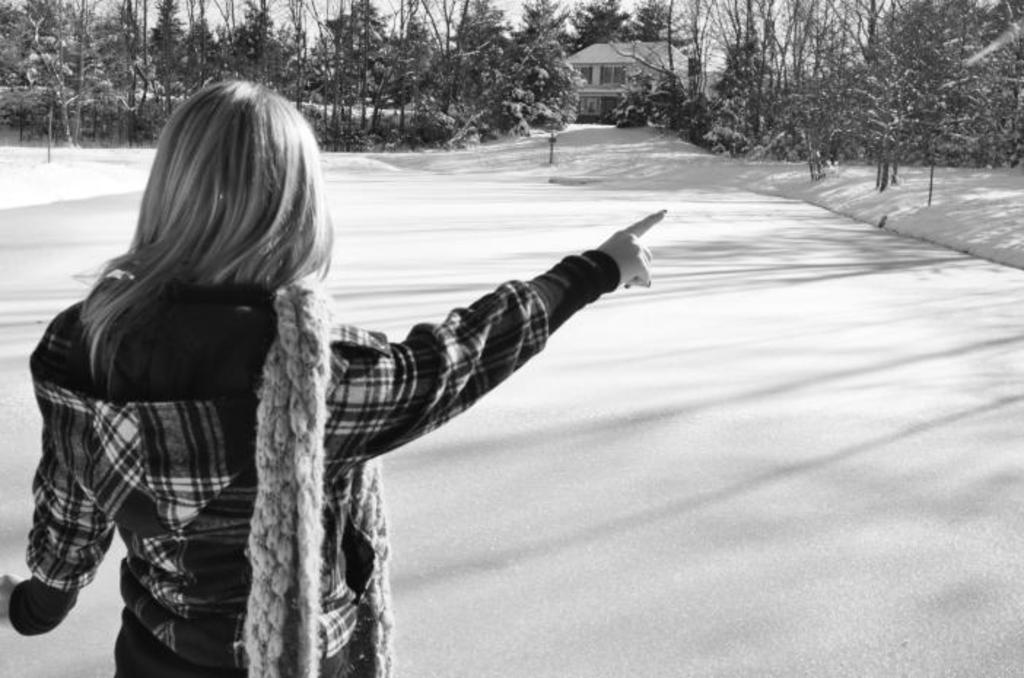What is the main subject of the image? There is a person standing in the image. Where is the person standing? The person is standing on the ground. What structures can be seen in the image? There is a building and a house in the image. What type of vegetation is present in the image? Trees are present in front of the building. What type of juice is being served in the house in the image? There is no juice or indication of any beverage being served in the image. 